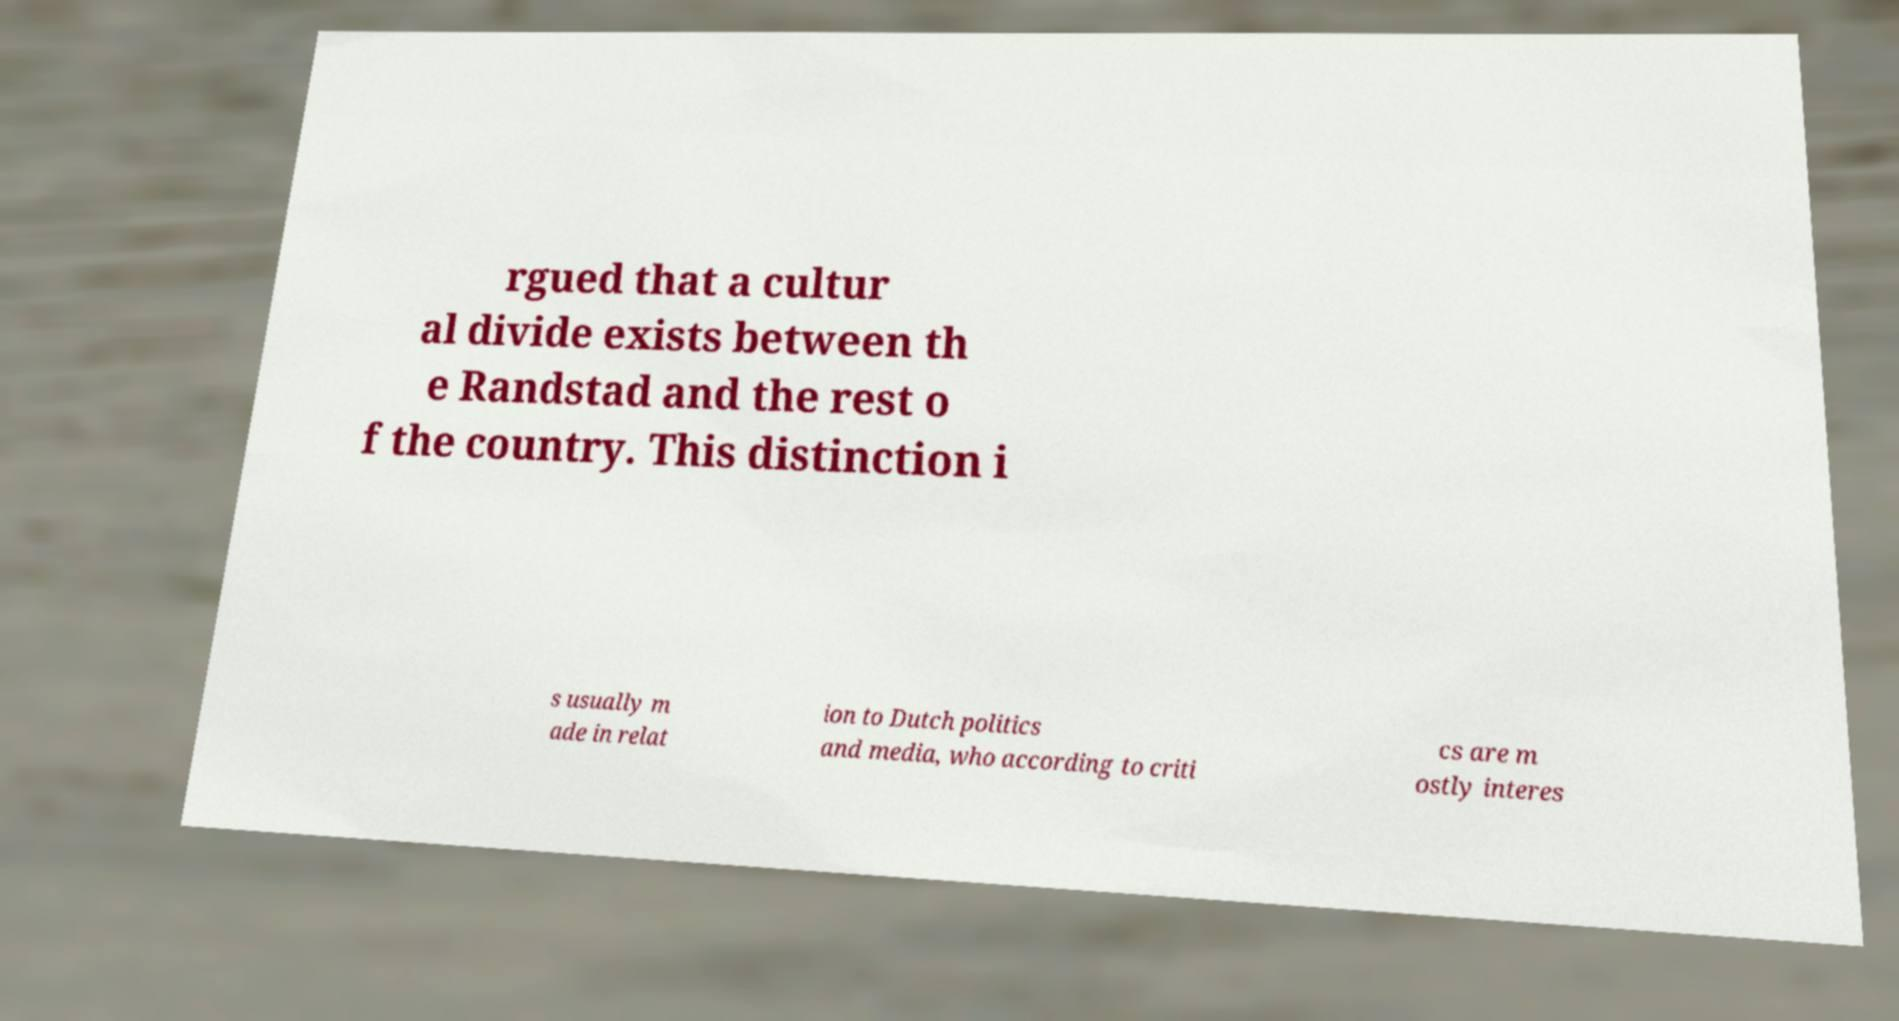Can you read and provide the text displayed in the image?This photo seems to have some interesting text. Can you extract and type it out for me? rgued that a cultur al divide exists between th e Randstad and the rest o f the country. This distinction i s usually m ade in relat ion to Dutch politics and media, who according to criti cs are m ostly interes 